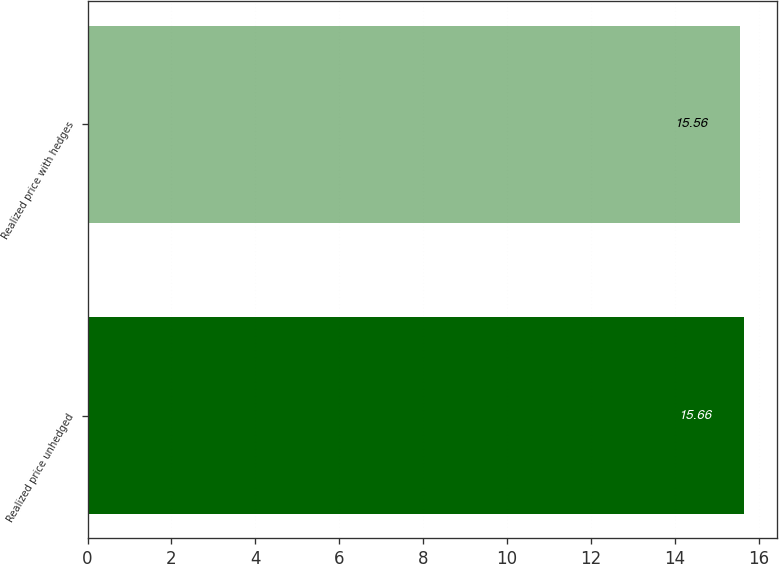<chart> <loc_0><loc_0><loc_500><loc_500><bar_chart><fcel>Realized price unhedged<fcel>Realized price with hedges<nl><fcel>15.66<fcel>15.56<nl></chart> 